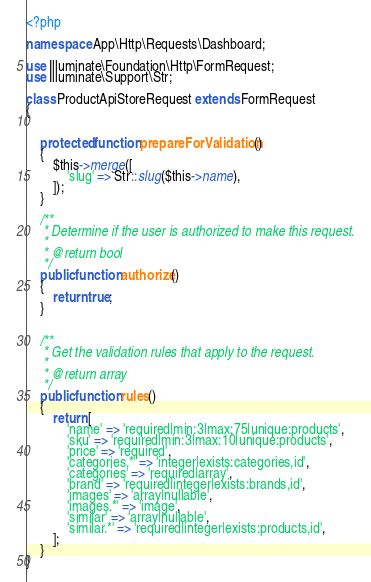<code> <loc_0><loc_0><loc_500><loc_500><_PHP_><?php

namespace App\Http\Requests\Dashboard;

use Illuminate\Foundation\Http\FormRequest;
use Illuminate\Support\Str;

class ProductApiStoreRequest extends FormRequest
{


    protected function prepareForValidation()
    {
        $this->merge([
            'slug' => Str::slug($this->name),
        ]);
    }

    /**
     * Determine if the user is authorized to make this request.
     *
     * @return bool
     */
    public function authorize()
    {
        return true;
    }


    /**
     * Get the validation rules that apply to the request.
     *
     * @return array
     */
    public function rules()
    {
        return [
            'name' => 'required|min:3|max:75|unique:products',
            'sku' => 'required|min:3|max:10|unique:products',
            'price' => 'required',
            'categories.*' => 'integer|exists:categories,id',
            'categories' => 'required|array',
            'brand' => 'required|integer|exists:brands,id',
            'images' => 'array|nullable',
            'images.*' => 'image',
            'similar' => 'array|nullable',
            'similar.*' => 'required|integer|exists:products,id',
        ];
    }
}
</code> 